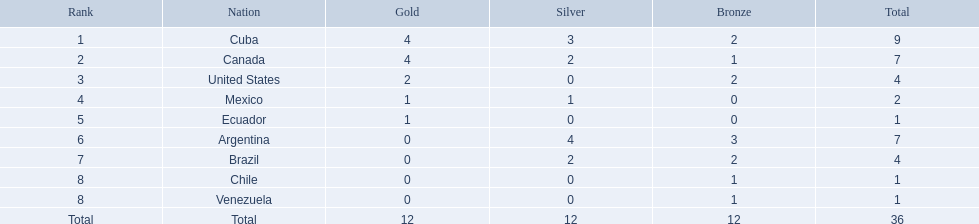What were all of the nations involved in the canoeing at the 2011 pan american games? Cuba, Canada, United States, Mexico, Ecuador, Argentina, Brazil, Chile, Venezuela, Total. Of these, which had a numbered rank? Cuba, Canada, United States, Mexico, Ecuador, Argentina, Brazil, Chile, Venezuela. From these, which had the highest number of bronze? Argentina. 